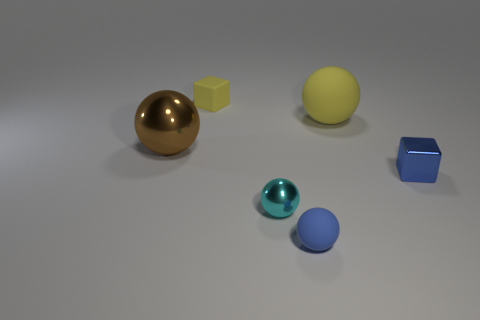Add 1 tiny cyan rubber spheres. How many objects exist? 7 Subtract all blocks. How many objects are left? 4 Add 4 blocks. How many blocks exist? 6 Subtract 0 gray balls. How many objects are left? 6 Subtract all tiny purple metal cubes. Subtract all blue shiny blocks. How many objects are left? 5 Add 1 tiny cyan metallic balls. How many tiny cyan metallic balls are left? 2 